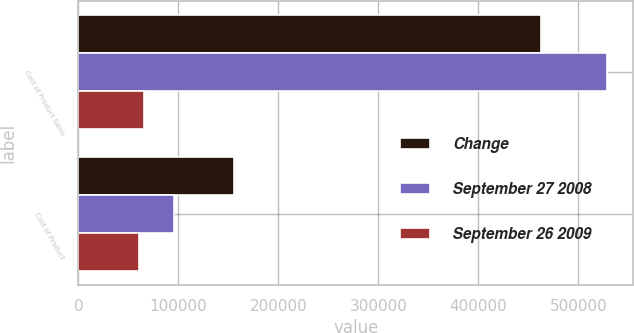Convert chart. <chart><loc_0><loc_0><loc_500><loc_500><stacked_bar_chart><ecel><fcel>Cost of Product Sales<fcel>Cost of Product<nl><fcel>Change<fcel>463066<fcel>155519<nl><fcel>September 27 2008<fcel>528528<fcel>95310<nl><fcel>September 26 2009<fcel>65462<fcel>60209<nl></chart> 